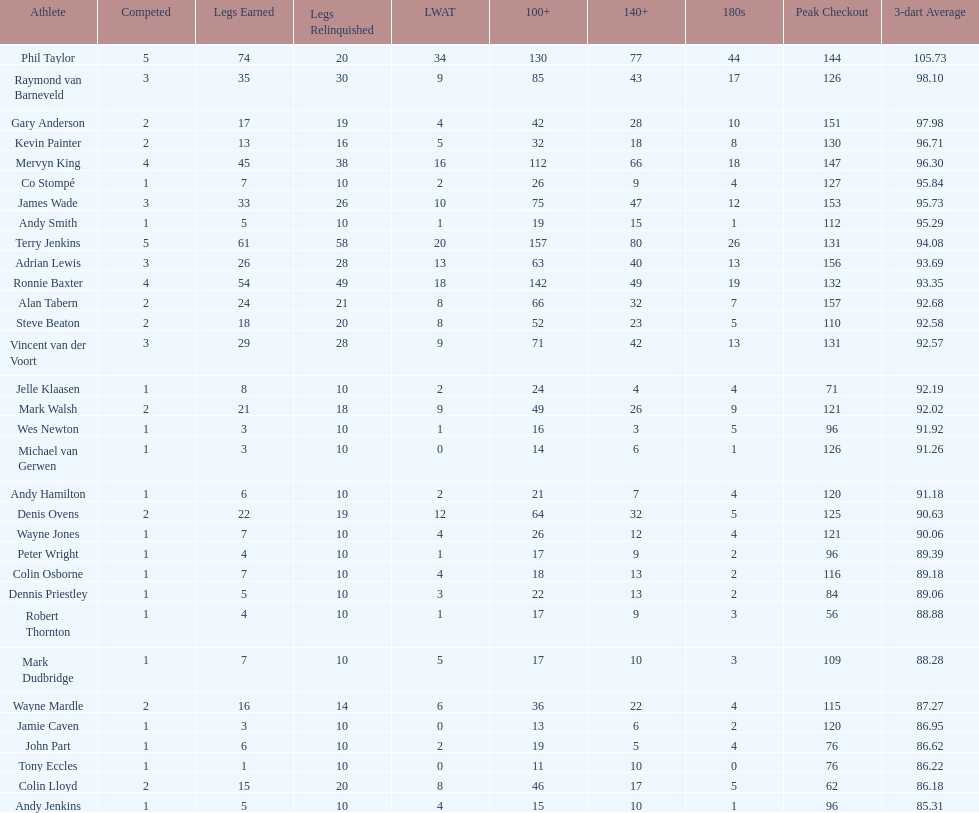What is the name of the next player after mark walsh? Wes Newton. 